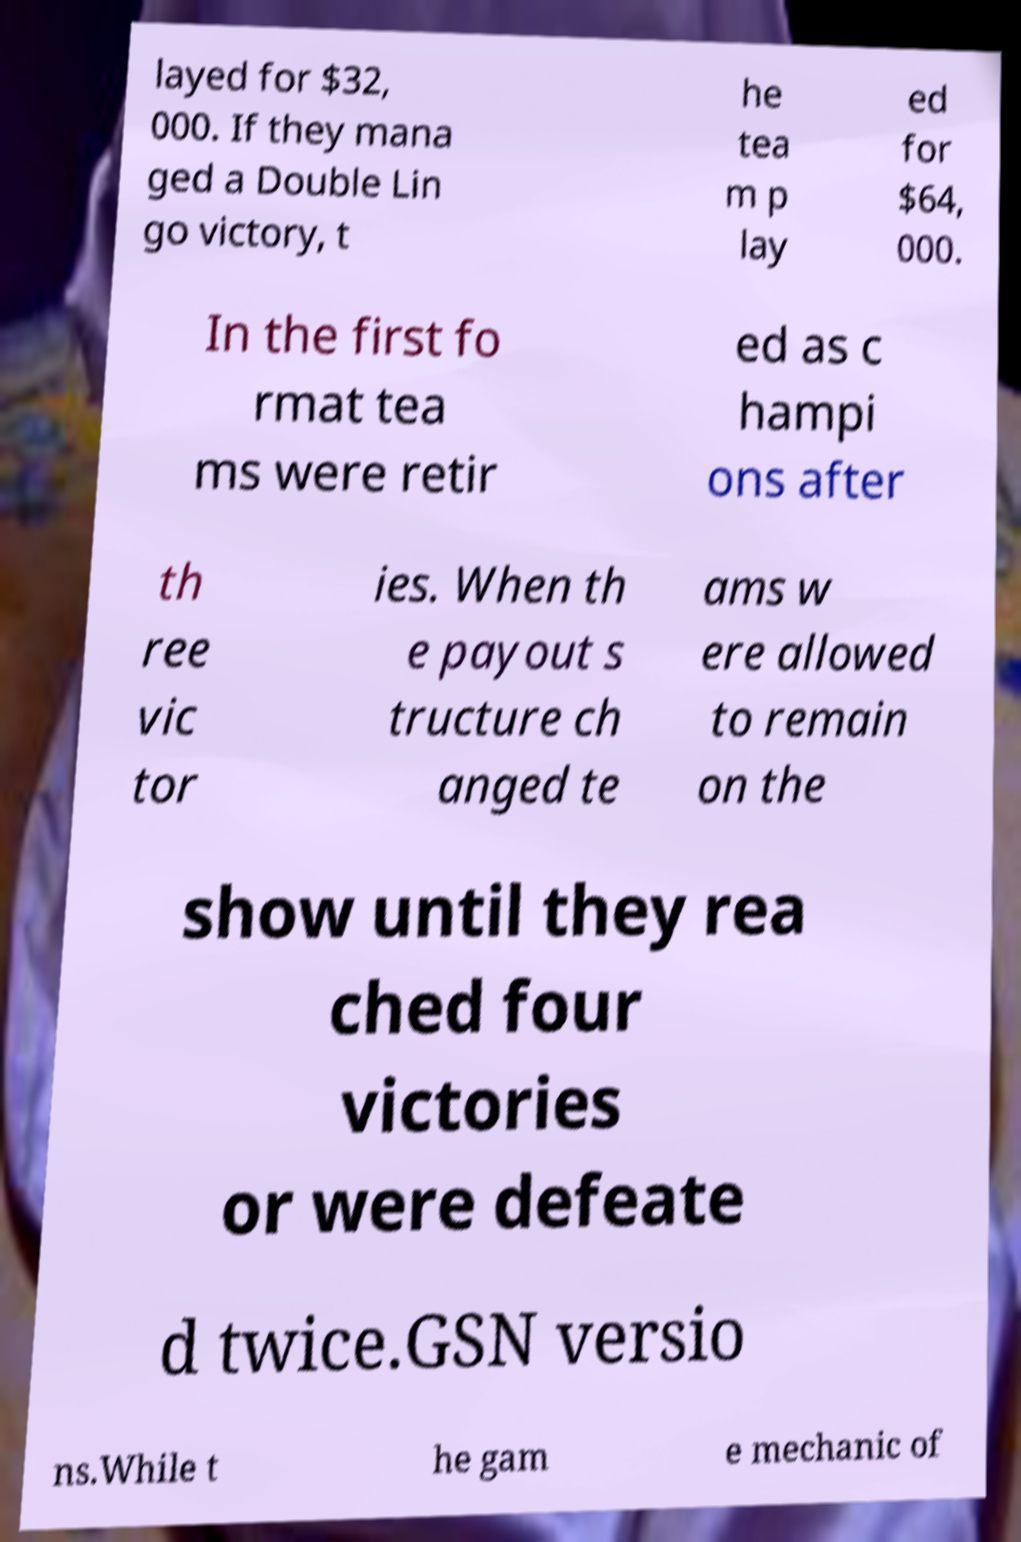Can you accurately transcribe the text from the provided image for me? layed for $32, 000. If they mana ged a Double Lin go victory, t he tea m p lay ed for $64, 000. In the first fo rmat tea ms were retir ed as c hampi ons after th ree vic tor ies. When th e payout s tructure ch anged te ams w ere allowed to remain on the show until they rea ched four victories or were defeate d twice.GSN versio ns.While t he gam e mechanic of 